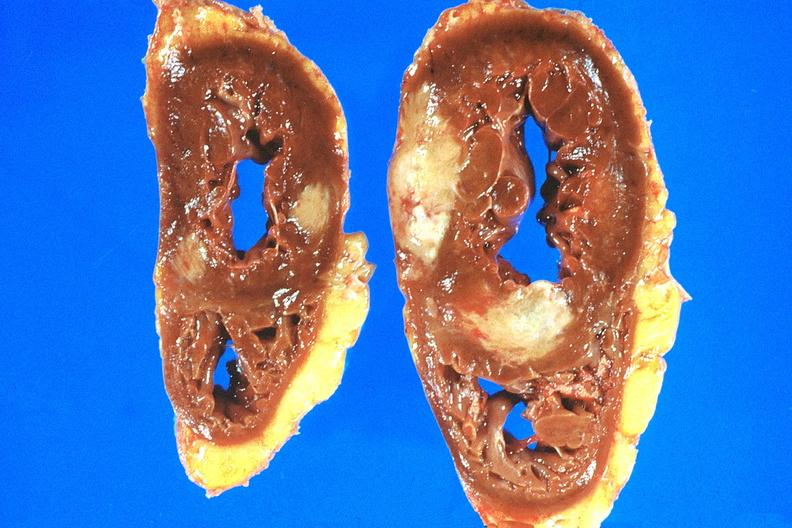does metastatic carcinoma prostate show heart, metastatic mesothelioma?
Answer the question using a single word or phrase. No 